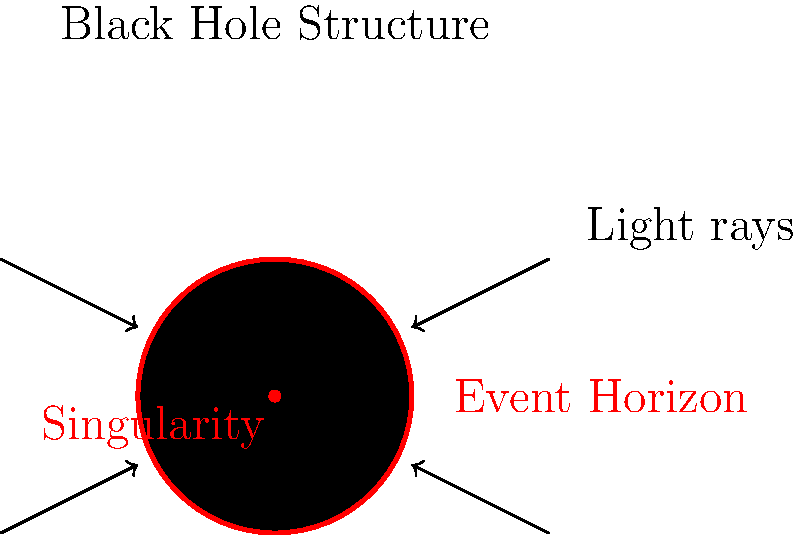In the context of a black hole's structure, imagine you're composing a song about the journey of light near this cosmic phenomenon. Which part of the black hole acts as the "point of no return" for light, beyond which even your most powerful vocal notes couldn't escape? To understand this concept, let's break it down step-by-step:

1. A black hole is an extremely dense region of space with incredibly strong gravitational pull.

2. The structure of a black hole consists of several key components:
   a) The singularity: The center of the black hole where matter is compressed to infinite density.
   b) The event horizon: A boundary around the black hole.

3. The event horizon is crucial in this context. It's often called the "point of no return" because:
   a) Any object or light that crosses this boundary cannot escape the black hole's gravitational pull.
   b) Even light, the fastest thing in the universe, cannot escape once it passes this point.

4. If we relate this to music:
   a) Imagine your voice as light waves traveling through space.
   b) As you get closer to the black hole, your "musical notes" (light) would be stretched and distorted due to the intense gravity.
   c) Once your "notes" cross the event horizon, they would be trapped forever inside the black hole, unable to reach any audience.

5. This phenomenon is why black holes appear completely dark - no light can escape from beyond the event horizon to reach our eyes or instruments.

Therefore, in the context of your musical journey through a black hole, the event horizon would be the critical boundary beyond which your "musical light" could never return.
Answer: Event horizon 